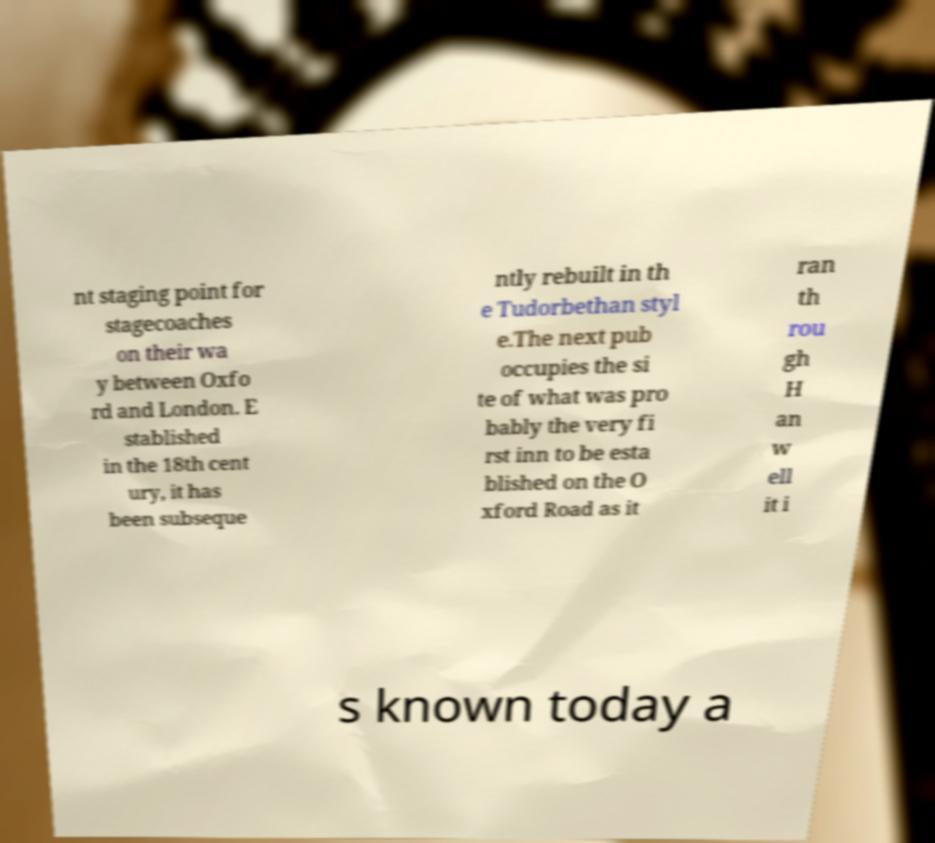Can you accurately transcribe the text from the provided image for me? nt staging point for stagecoaches on their wa y between Oxfo rd and London. E stablished in the 18th cent ury, it has been subseque ntly rebuilt in th e Tudorbethan styl e.The next pub occupies the si te of what was pro bably the very fi rst inn to be esta blished on the O xford Road as it ran th rou gh H an w ell it i s known today a 